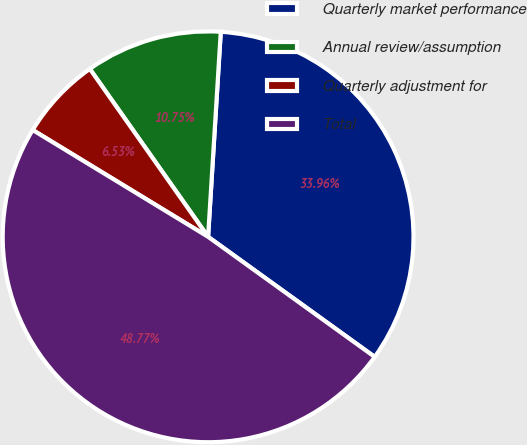<chart> <loc_0><loc_0><loc_500><loc_500><pie_chart><fcel>Quarterly market performance<fcel>Annual review/assumption<fcel>Quarterly adjustment for<fcel>Total<nl><fcel>33.96%<fcel>10.75%<fcel>6.53%<fcel>48.77%<nl></chart> 